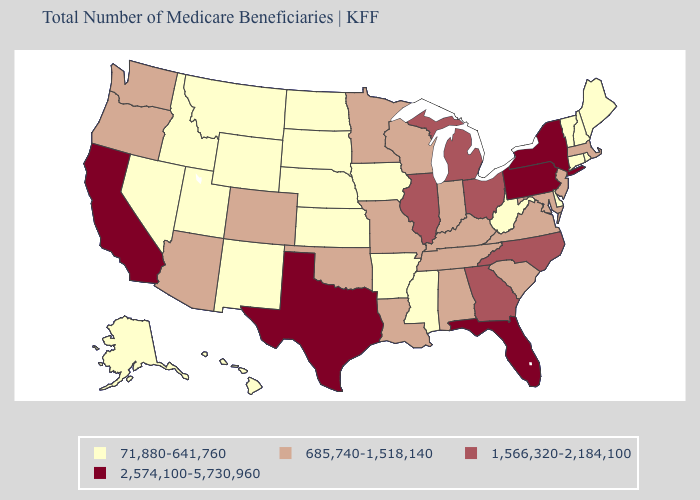What is the highest value in the South ?
Short answer required. 2,574,100-5,730,960. Does Indiana have the same value as Louisiana?
Quick response, please. Yes. Name the states that have a value in the range 685,740-1,518,140?
Concise answer only. Alabama, Arizona, Colorado, Indiana, Kentucky, Louisiana, Maryland, Massachusetts, Minnesota, Missouri, New Jersey, Oklahoma, Oregon, South Carolina, Tennessee, Virginia, Washington, Wisconsin. What is the highest value in the South ?
Answer briefly. 2,574,100-5,730,960. Does South Dakota have the highest value in the MidWest?
Be succinct. No. What is the value of Florida?
Answer briefly. 2,574,100-5,730,960. Is the legend a continuous bar?
Short answer required. No. Name the states that have a value in the range 2,574,100-5,730,960?
Concise answer only. California, Florida, New York, Pennsylvania, Texas. Does Iowa have the same value as Nevada?
Be succinct. Yes. Does Texas have the highest value in the USA?
Give a very brief answer. Yes. What is the value of Georgia?
Answer briefly. 1,566,320-2,184,100. Which states have the lowest value in the USA?
Write a very short answer. Alaska, Arkansas, Connecticut, Delaware, Hawaii, Idaho, Iowa, Kansas, Maine, Mississippi, Montana, Nebraska, Nevada, New Hampshire, New Mexico, North Dakota, Rhode Island, South Dakota, Utah, Vermont, West Virginia, Wyoming. Which states have the highest value in the USA?
Quick response, please. California, Florida, New York, Pennsylvania, Texas. What is the lowest value in the MidWest?
Be succinct. 71,880-641,760. What is the highest value in the Northeast ?
Short answer required. 2,574,100-5,730,960. 